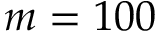<formula> <loc_0><loc_0><loc_500><loc_500>m = 1 0 0</formula> 